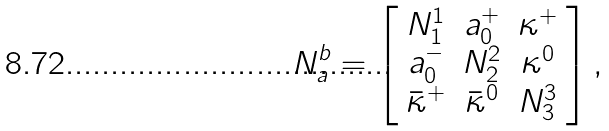Convert formula to latex. <formula><loc_0><loc_0><loc_500><loc_500>N _ { a } ^ { b } = \left [ \begin{array} { c c c } N ^ { 1 } _ { 1 } & a _ { 0 } ^ { + } & \kappa ^ { + } \\ a _ { 0 } ^ { - } & N ^ { 2 } _ { 2 } & \kappa ^ { 0 } \\ { \bar { \kappa } } ^ { + } & { \bar { \kappa } } ^ { 0 } & N ^ { 3 } _ { 3 } \\ \end{array} \right ] ,</formula> 